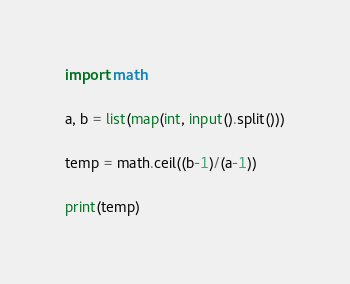Convert code to text. <code><loc_0><loc_0><loc_500><loc_500><_Python_>import math

a, b = list(map(int, input().split()))

temp = math.ceil((b-1)/(a-1))

print(temp)</code> 